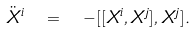Convert formula to latex. <formula><loc_0><loc_0><loc_500><loc_500>\ddot { X } ^ { i } \ = \ - [ [ X ^ { i } , X ^ { j } ] , X ^ { j } ] .</formula> 